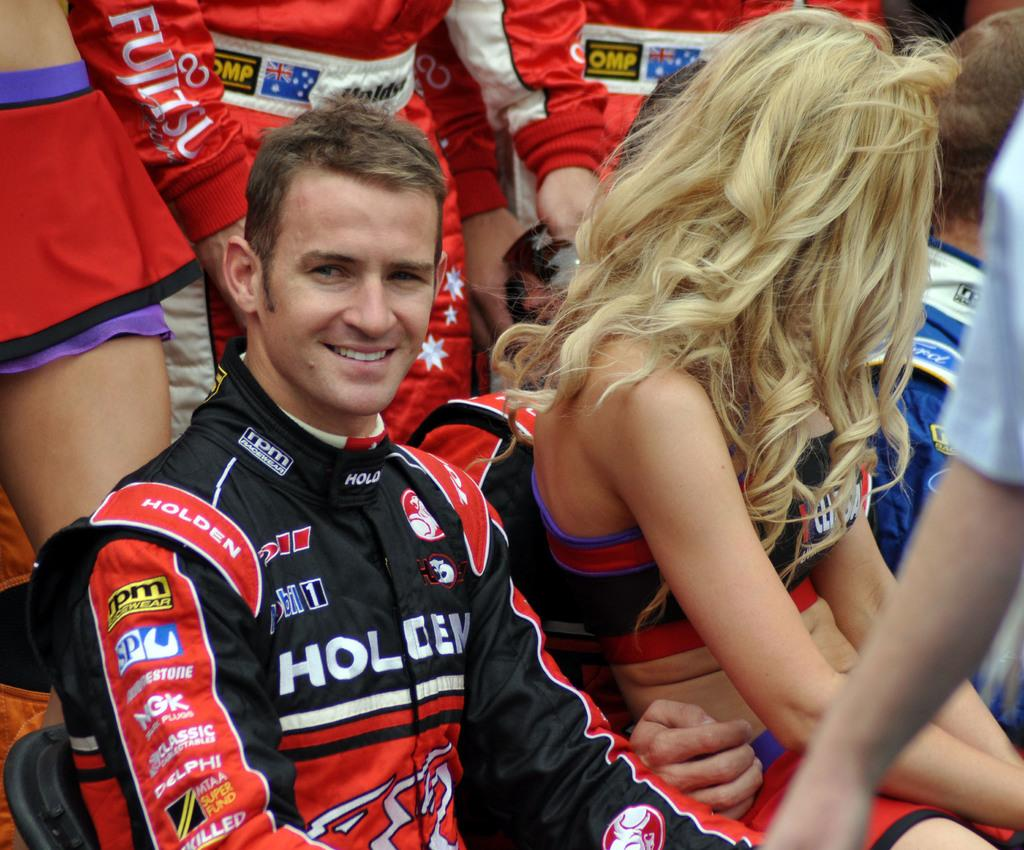<image>
Share a concise interpretation of the image provided. A race car driver whose suite reads "Holden" sits in the stands next to a cheerleader. 